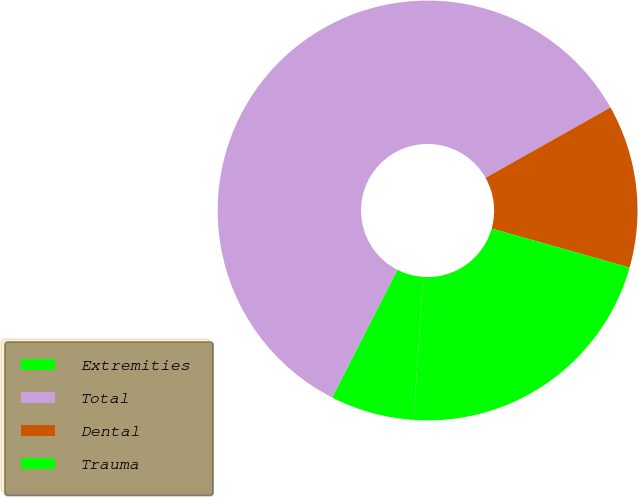Convert chart to OTSL. <chart><loc_0><loc_0><loc_500><loc_500><pie_chart><fcel>Extremities<fcel>Total<fcel>Dental<fcel>Trauma<nl><fcel>6.46%<fcel>59.32%<fcel>12.55%<fcel>21.67%<nl></chart> 